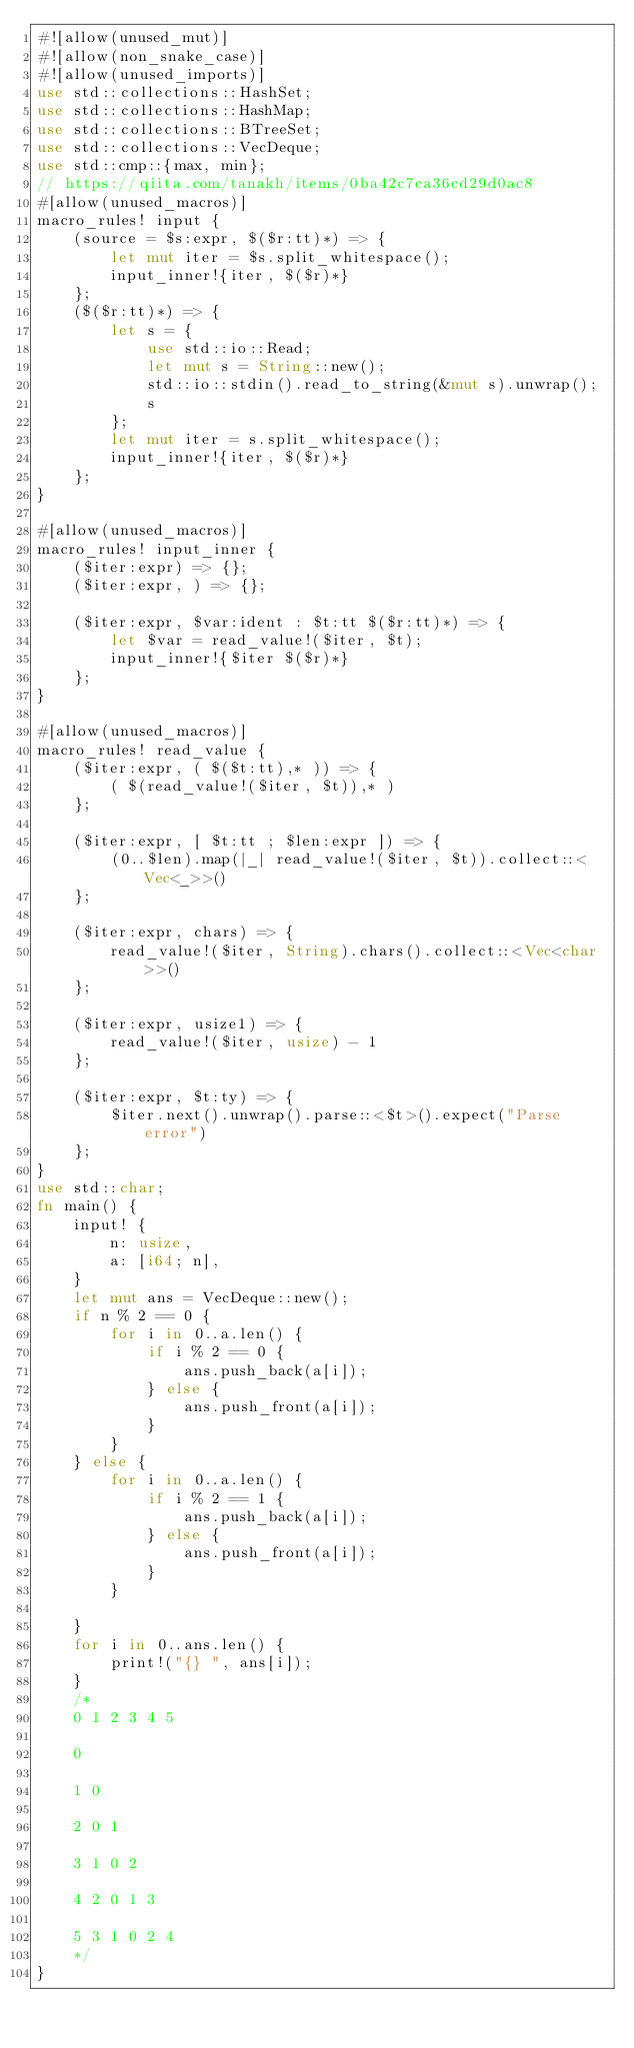Convert code to text. <code><loc_0><loc_0><loc_500><loc_500><_Rust_>#![allow(unused_mut)]
#![allow(non_snake_case)]
#![allow(unused_imports)]
use std::collections::HashSet;
use std::collections::HashMap;
use std::collections::BTreeSet;
use std::collections::VecDeque;
use std::cmp::{max, min};
// https://qiita.com/tanakh/items/0ba42c7ca36cd29d0ac8
#[allow(unused_macros)]
macro_rules! input {
    (source = $s:expr, $($r:tt)*) => {
        let mut iter = $s.split_whitespace();
        input_inner!{iter, $($r)*}
    };
    ($($r:tt)*) => {
        let s = {
            use std::io::Read;
            let mut s = String::new();
            std::io::stdin().read_to_string(&mut s).unwrap();
            s
        };
        let mut iter = s.split_whitespace();
        input_inner!{iter, $($r)*}
    };
}

#[allow(unused_macros)]
macro_rules! input_inner {
    ($iter:expr) => {};
    ($iter:expr, ) => {};

    ($iter:expr, $var:ident : $t:tt $($r:tt)*) => {
        let $var = read_value!($iter, $t);
        input_inner!{$iter $($r)*}
    };
}

#[allow(unused_macros)]
macro_rules! read_value {
    ($iter:expr, ( $($t:tt),* )) => {
        ( $(read_value!($iter, $t)),* )
    };

    ($iter:expr, [ $t:tt ; $len:expr ]) => {
        (0..$len).map(|_| read_value!($iter, $t)).collect::<Vec<_>>()
    };

    ($iter:expr, chars) => {
        read_value!($iter, String).chars().collect::<Vec<char>>()
    };

    ($iter:expr, usize1) => {
        read_value!($iter, usize) - 1
    };

    ($iter:expr, $t:ty) => {
        $iter.next().unwrap().parse::<$t>().expect("Parse error")
    };
}
use std::char;
fn main() {
    input! {
        n: usize,
        a: [i64; n],
    }
    let mut ans = VecDeque::new();
    if n % 2 == 0 {
        for i in 0..a.len() {
            if i % 2 == 0 {
                ans.push_back(a[i]);
            } else {
                ans.push_front(a[i]);
            }
        }
    } else {
        for i in 0..a.len() {
            if i % 2 == 1 {
                ans.push_back(a[i]);
            } else {
                ans.push_front(a[i]);
            }
        }

    }
    for i in 0..ans.len() {
        print!("{} ", ans[i]);
    }
    /*
    0 1 2 3 4 5

    0

    1 0

    2 0 1

    3 1 0 2

    4 2 0 1 3

    5 3 1 0 2 4
    */
}</code> 